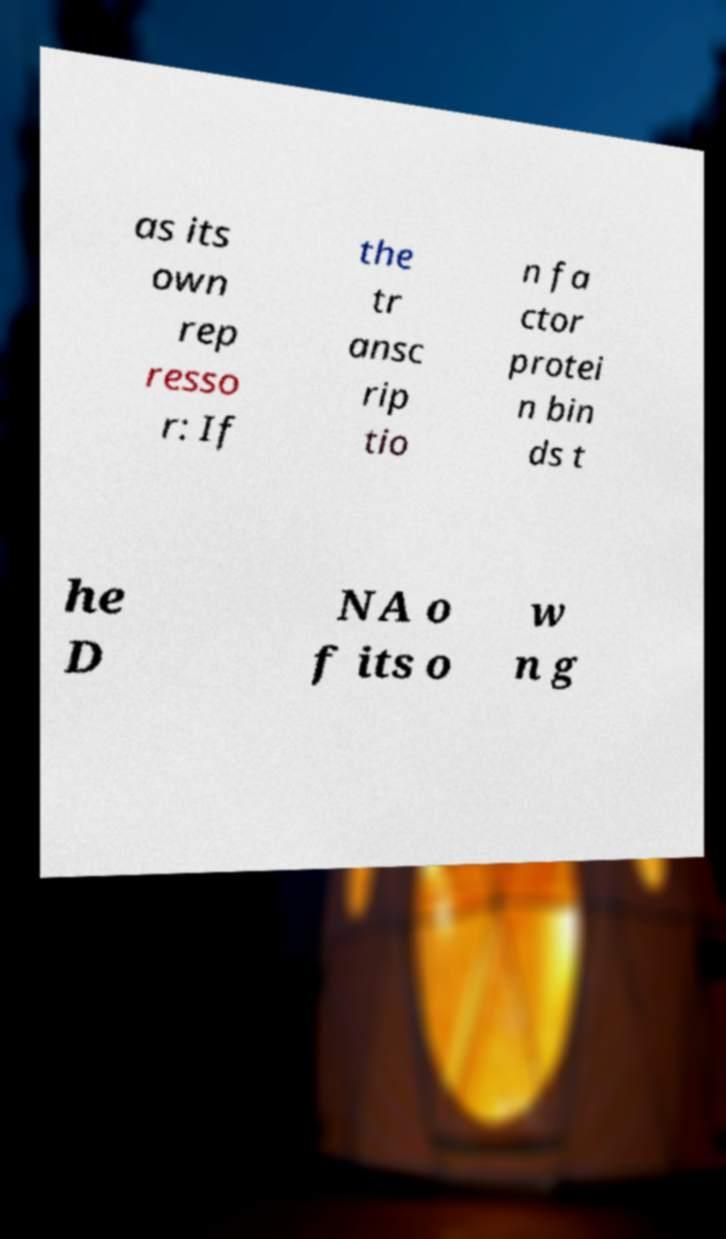Please identify and transcribe the text found in this image. as its own rep resso r: If the tr ansc rip tio n fa ctor protei n bin ds t he D NA o f its o w n g 